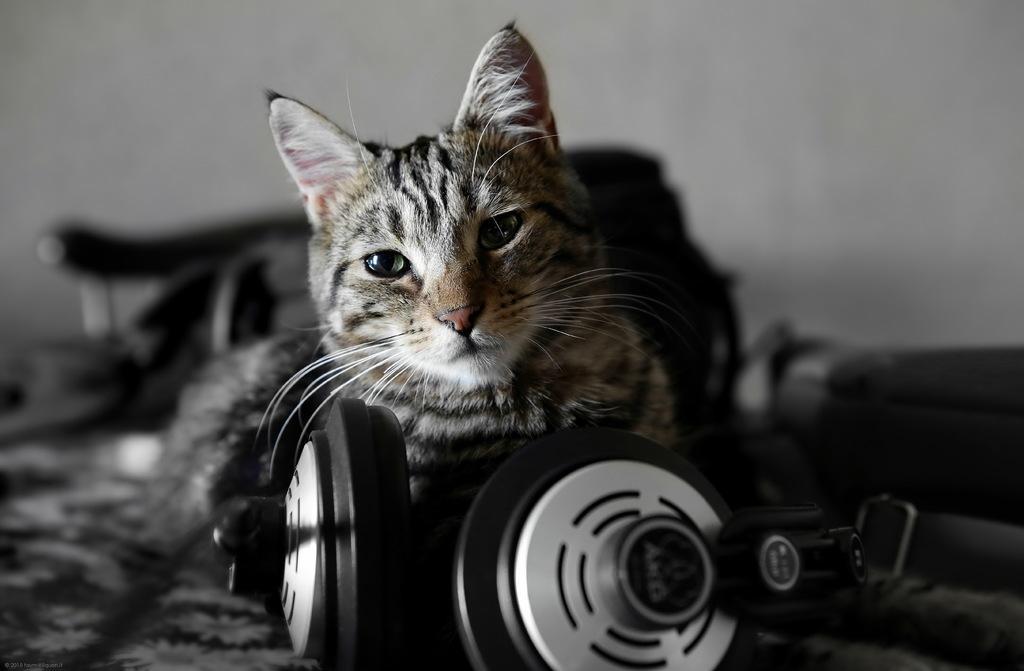Can you describe this image briefly? In the image there is a cat laying on floor in front of headset and behind it there is wall with some things in front of it, this seems to be a black and white picture. 